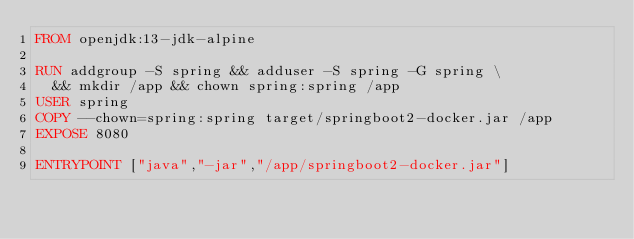<code> <loc_0><loc_0><loc_500><loc_500><_Dockerfile_>FROM openjdk:13-jdk-alpine

RUN addgroup -S spring && adduser -S spring -G spring \
  && mkdir /app && chown spring:spring /app
USER spring
COPY --chown=spring:spring target/springboot2-docker.jar /app
EXPOSE 8080

ENTRYPOINT ["java","-jar","/app/springboot2-docker.jar"]
</code> 